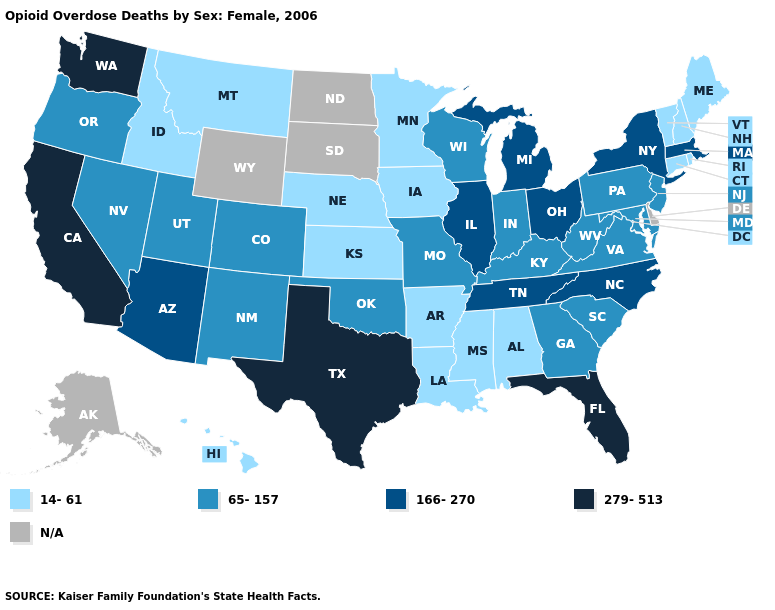Does Connecticut have the lowest value in the Northeast?
Quick response, please. Yes. Name the states that have a value in the range 279-513?
Quick response, please. California, Florida, Texas, Washington. Name the states that have a value in the range N/A?
Short answer required. Alaska, Delaware, North Dakota, South Dakota, Wyoming. Name the states that have a value in the range N/A?
Be succinct. Alaska, Delaware, North Dakota, South Dakota, Wyoming. How many symbols are there in the legend?
Answer briefly. 5. What is the value of Iowa?
Short answer required. 14-61. Among the states that border Nebraska , does Iowa have the highest value?
Keep it brief. No. Name the states that have a value in the range 279-513?
Short answer required. California, Florida, Texas, Washington. What is the highest value in states that border Pennsylvania?
Be succinct. 166-270. Name the states that have a value in the range N/A?
Quick response, please. Alaska, Delaware, North Dakota, South Dakota, Wyoming. Does Idaho have the lowest value in the West?
Quick response, please. Yes. Which states have the highest value in the USA?
Write a very short answer. California, Florida, Texas, Washington. Does Kansas have the highest value in the MidWest?
Be succinct. No. 